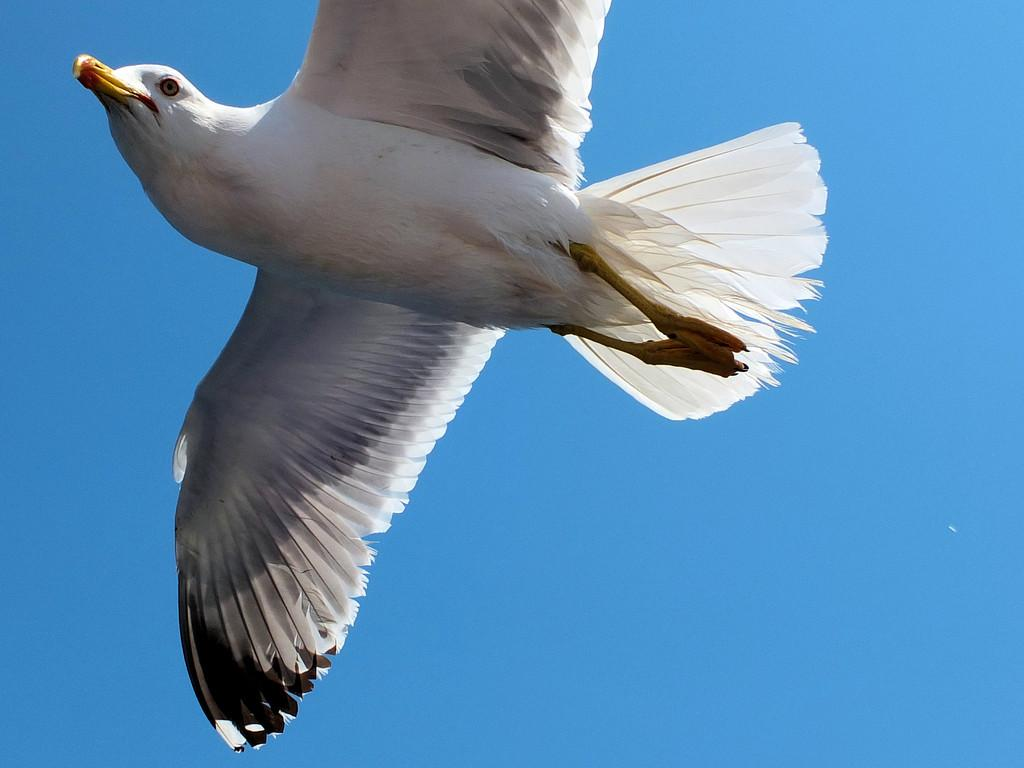What type of animal can be seen in the image? There is a bird in the image. Can you describe the colors of the bird? The bird has multiple colors, including white, grey, yellow, orange, and black. What is the bird doing in the image? The bird is flying in the air. What can be seen in the background of the image? The sky is visible in the background of the image. Can you see the seashore in the background of the image? No, the seashore is not visible in the background of the image; it is the sky that can be seen. Are there any crows present in the image? No, there are no crows present in the image; it features a bird with multiple colors. 